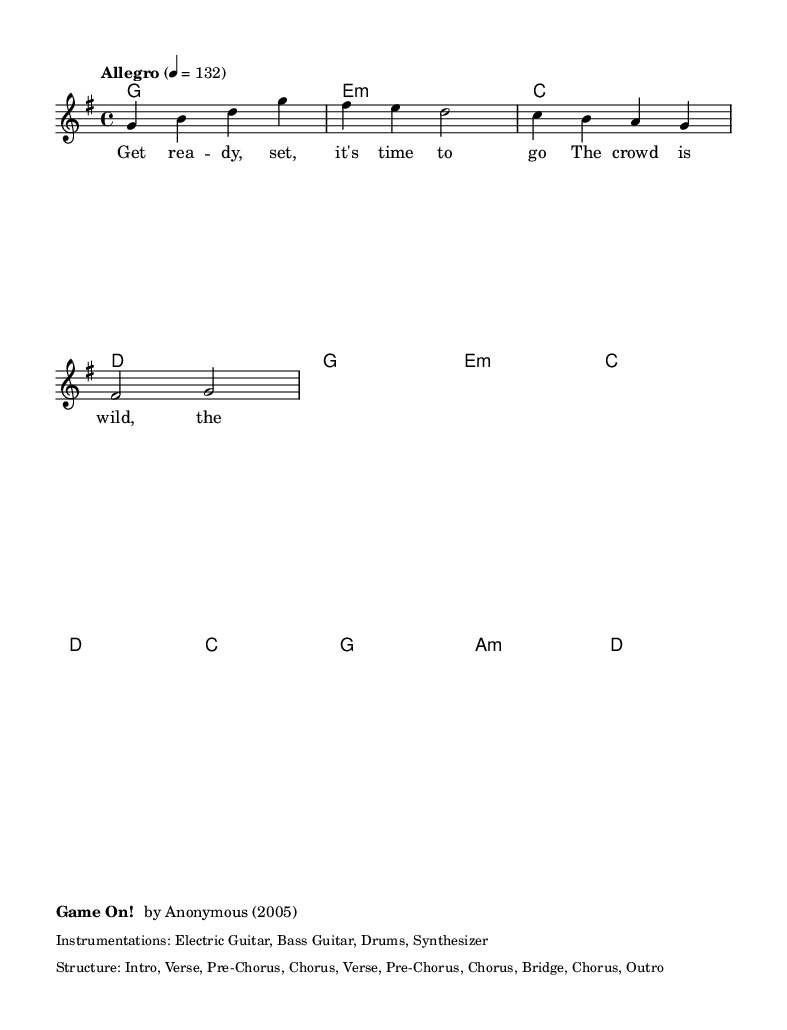What is the key signature of this music? The key signature indicates the key in which the piece is written. In the code, the line `\key g \major` specifies G major, which has one sharp (F#).
Answer: G major What is the time signature of this music? The time signature indicates the number of beats in each measure. The line `\time 4/4` shows that there are 4 beats in each measure.
Answer: 4/4 What is the tempo marking specified in the piece? The tempo is indicated by the line containing `\tempo "Allegro" 4 = 132`. This tells us the piece should be played at a lively pace of 132 beats per minute.
Answer: Allegro How many unique sections are there in the structure? The structure is listed as "Intro, Verse, Pre-Chorus, Chorus, Verse, Pre-Chorus, Chorus, Bridge, Chorus, Outro". Counting these, there are 9 unique sections.
Answer: 9 What is the first chord played in the score? The first chord is defined in the harmonies section with `g1`, which indicates that G major is the first chord played in the piece.
Answer: G What type of instrumentation is used for this piece? The instrumentation is described in the markup section which lists "Electric Guitar, Bass Guitar, Drums, Synthesizer". This outlines the instruments used in the arrangement.
Answer: Electric Guitar, Bass Guitar, Drums, Synthesizer What is the lyrical theme introduced in the first verse? The first verse includes the lyrics "Get ready, set, it's time to go / The crowd is wild, the tension grows", which sets an exciting sports-themed atmosphere.
Answer: Excitement and anticipation 